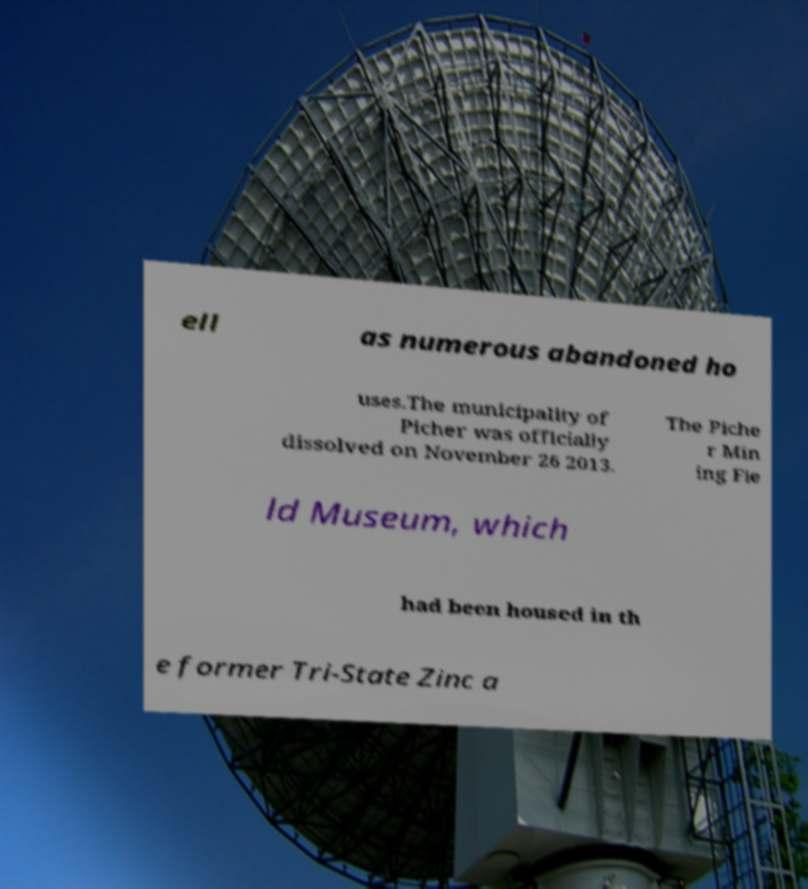Could you assist in decoding the text presented in this image and type it out clearly? ell as numerous abandoned ho uses.The municipality of Picher was officially dissolved on November 26 2013. The Piche r Min ing Fie ld Museum, which had been housed in th e former Tri-State Zinc a 